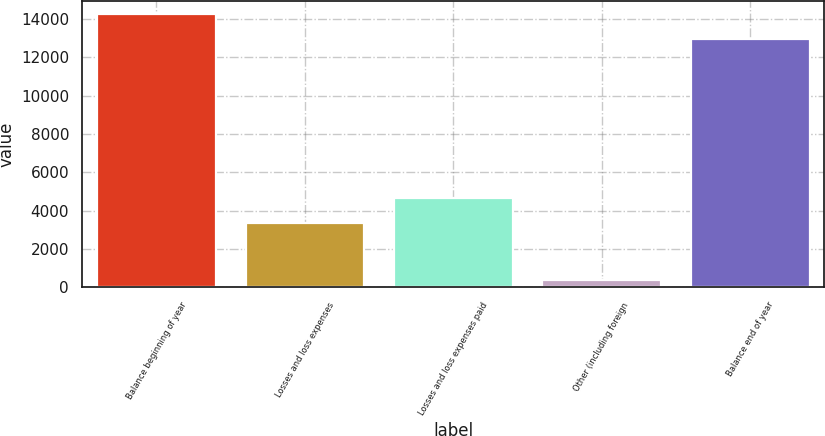Convert chart. <chart><loc_0><loc_0><loc_500><loc_500><bar_chart><fcel>Balance beginning of year<fcel>Losses and loss expenses<fcel>Losses and loss expenses paid<fcel>Other (including foreign<fcel>Balance end of year<nl><fcel>14248.3<fcel>3341<fcel>4654.3<fcel>387<fcel>12935<nl></chart> 